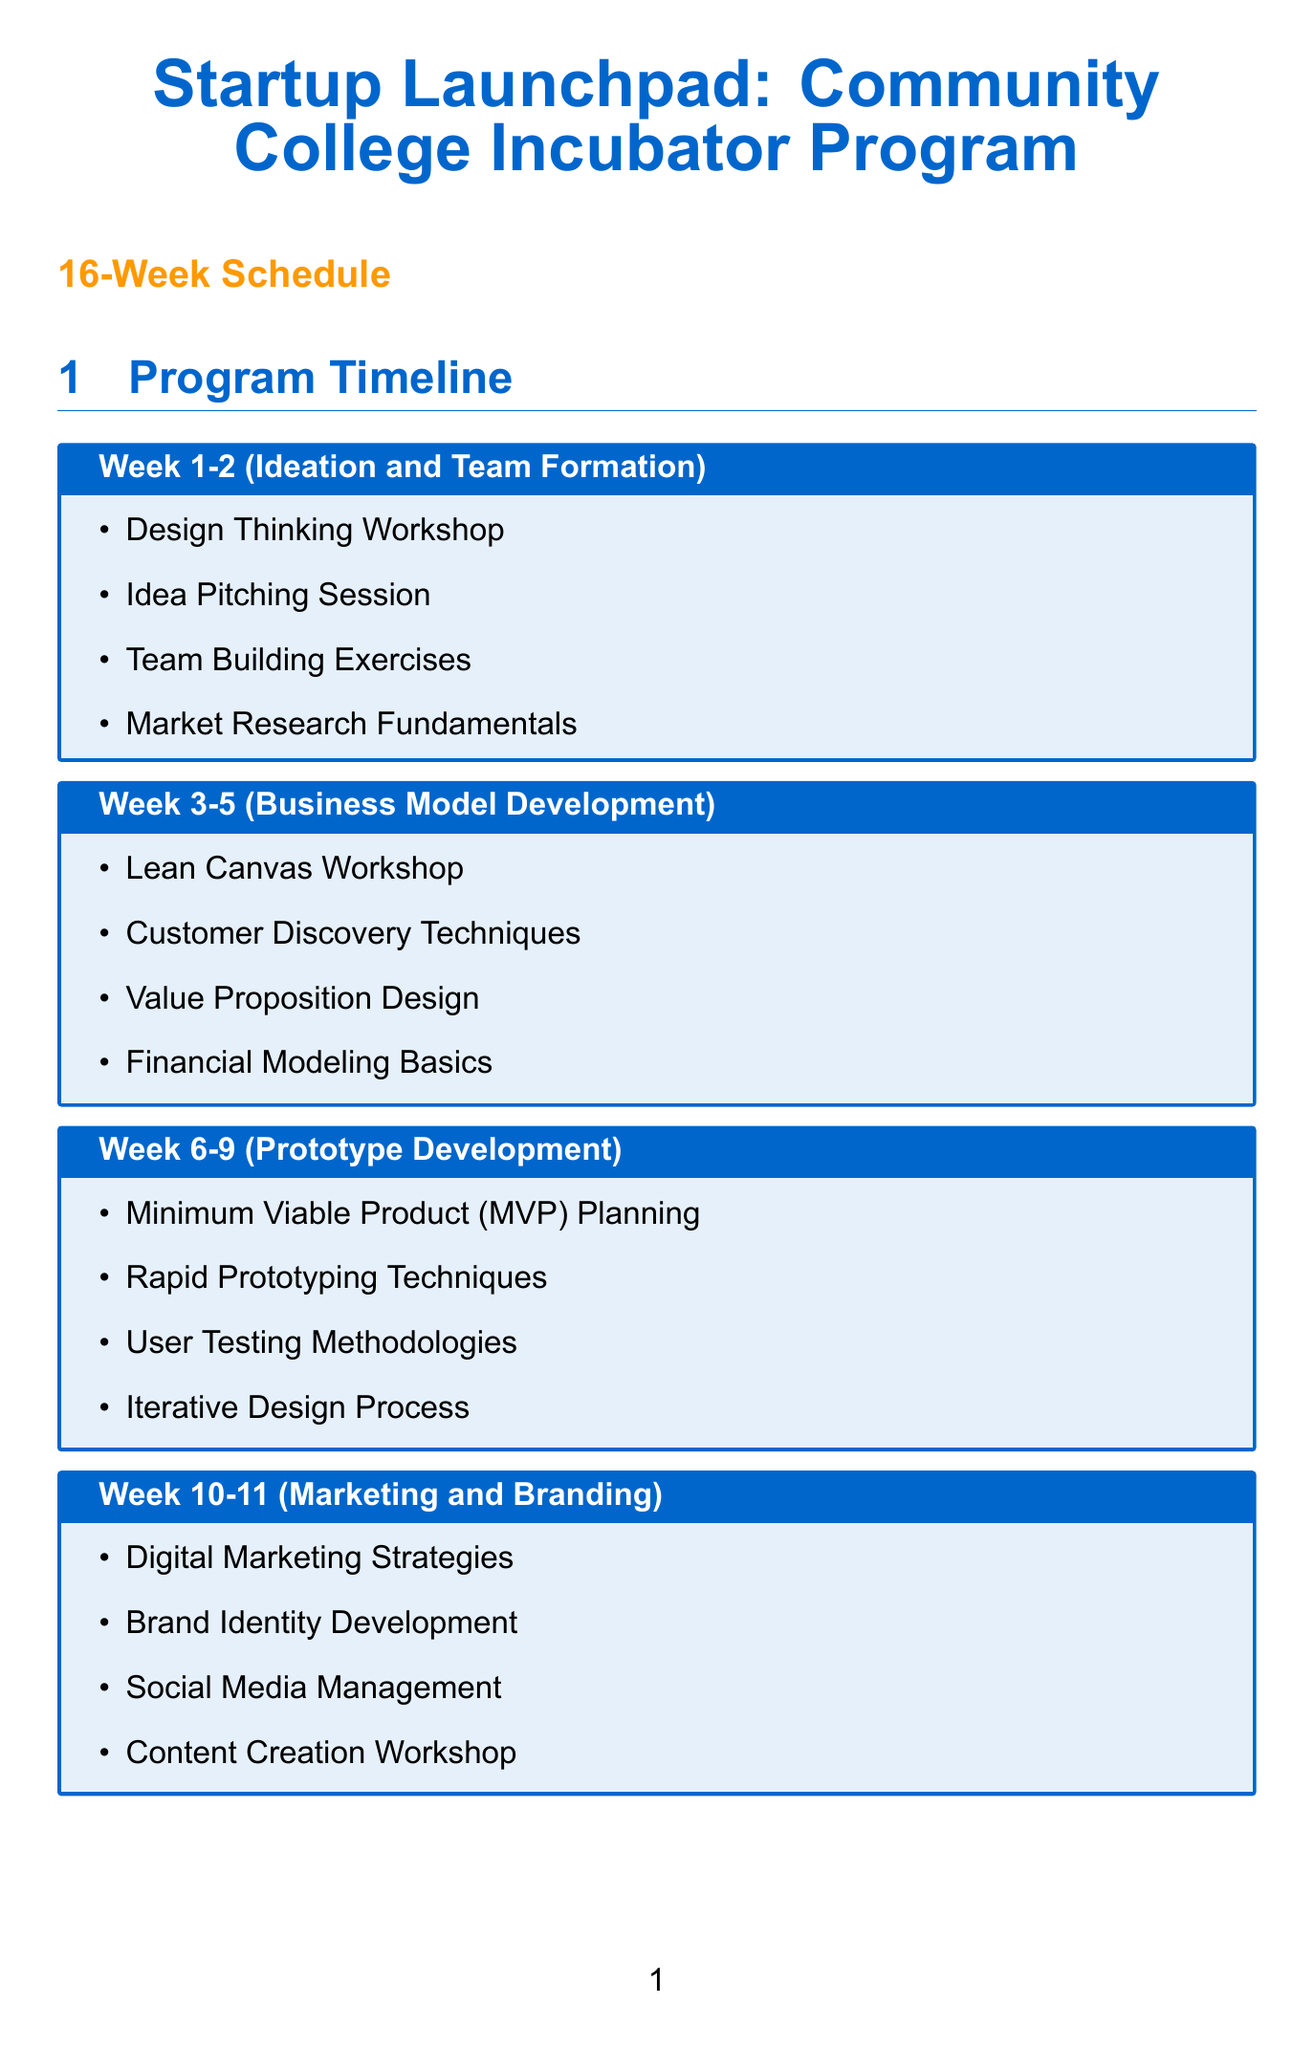What is the duration of the program? The program duration is specified at the beginning of the document.
Answer: 16 weeks How many weeks are allocated for Prototype Development? The number of weeks for Prototype Development is detailed under the corresponding phase.
Answer: 4 weeks Which activity is included in the Marketing and Branding phase? Activities listed under the Marketing and Branding phase provide specific examples.
Answer: Digital Marketing Strategies What is the name of the final event? The final event's name is mentioned in the section describing the overall program features.
Answer: Innovation Showcase Who are the mentors in the mentorship program? The document lists the types of mentors available within the mentorship program.
Answer: Local Entrepreneurs, Industry Experts, Alumni Founders, Venture Capitalists What is the contribution of Google for Startups? The document specifies contributions made by partnerships in their own section.
Answer: Cloud credits and technical mentorship How often do mentoring sessions occur? The frequency of mentoring sessions is clearly stated in the related box.
Answer: Weekly Which week is dedicated to Legal and Operational Setup? The week assigned to Legal and Operational Setup is mentioned in the schedule of phases.
Answer: Week 14 What is provided as a resource in the program? The resources available in the program are listed in their dedicated section.
Answer: Co-working Space 